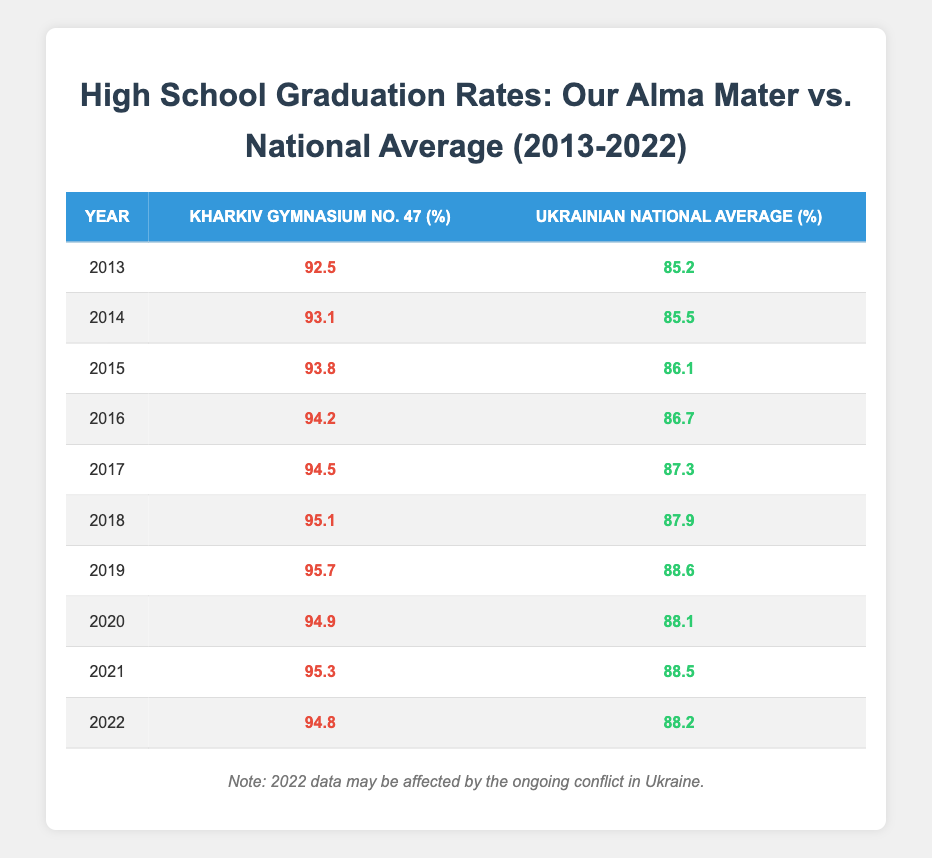What was the graduation rate for our alma mater in 2016? The table shows that the graduation rate for Kharkiv Gymnasium No. 47 in 2016 is 94.2%.
Answer: 94.2% What was the graduation rate for the Ukrainian national average in 2019? From the table, the Ukrainian national average graduation rate in 2019 was 88.6%.
Answer: 88.6% Which year had the highest graduation rate for our alma mater? Looking at the percentages for Kharkiv Gymnasium No. 47, the highest graduation rate was in 2019, with a rate of 95.7%.
Answer: 2019 Did the graduation rate for our alma mater ever drop below 92% during the period? Referring to the table, all rates for Kharkiv Gymnasium No. 47 were above 92% from 2013 to 2022. Therefore, the statement is false.
Answer: No What is the average graduation rate of Kharkiv Gymnasium No. 47 from 2013 to 2022? To calculate this, we add up all the rates: 92.5 + 93.1 + 93.8 + 94.2 + 94.5 + 95.1 + 95.7 + 94.9 + 95.3 + 94.8 = 949.0. There are 10 data points, so the average is 949.0 / 10 = 94.9%.
Answer: 94.9% What was the difference in graduation rates between our alma mater and the national average in 2021? In 2021, the graduation rate for Kharkiv Gymnasium No. 47 was 95.3% and for the national average it was 88.5%. The difference is 95.3 - 88.5 = 6.8%.
Answer: 6.8% Was the graduation rate for our alma mater higher than the national average every year? By examining the table, Kharkiv Gymnasium No. 47 had a higher rate than the national average in every year from 2013 to 2022. Thus, the statement is true.
Answer: Yes In which year did the national average first exceed 87%? The table indicates that the national average first exceeded 87% in 2017, when it was recorded at 87.3%.
Answer: 2017 